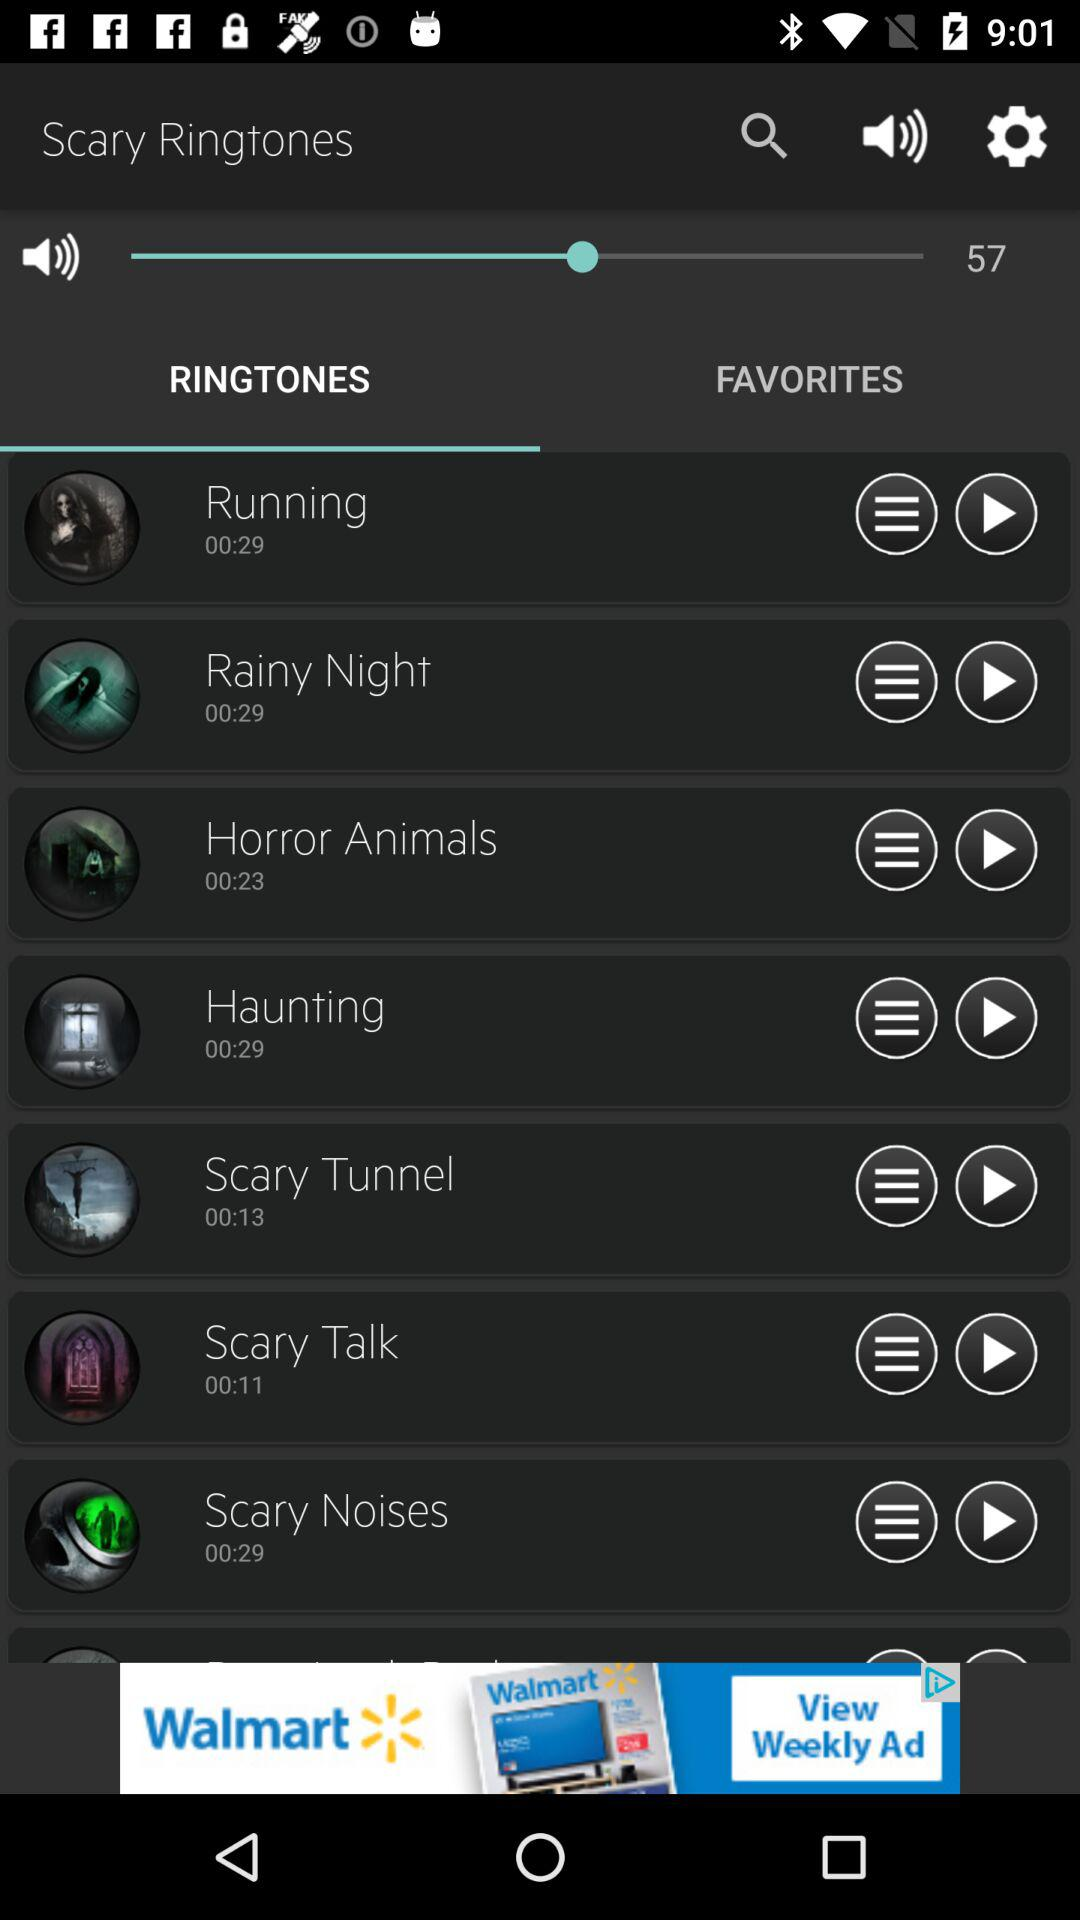What is the duration of the "Scary Talk" ringtone? The duration is 11 seconds. 